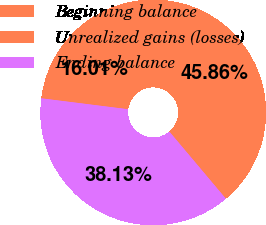Convert chart to OTSL. <chart><loc_0><loc_0><loc_500><loc_500><pie_chart><fcel>Beginning balance<fcel>Unrealized gains (losses)<fcel>Ending balance<nl><fcel>16.01%<fcel>45.86%<fcel>38.13%<nl></chart> 